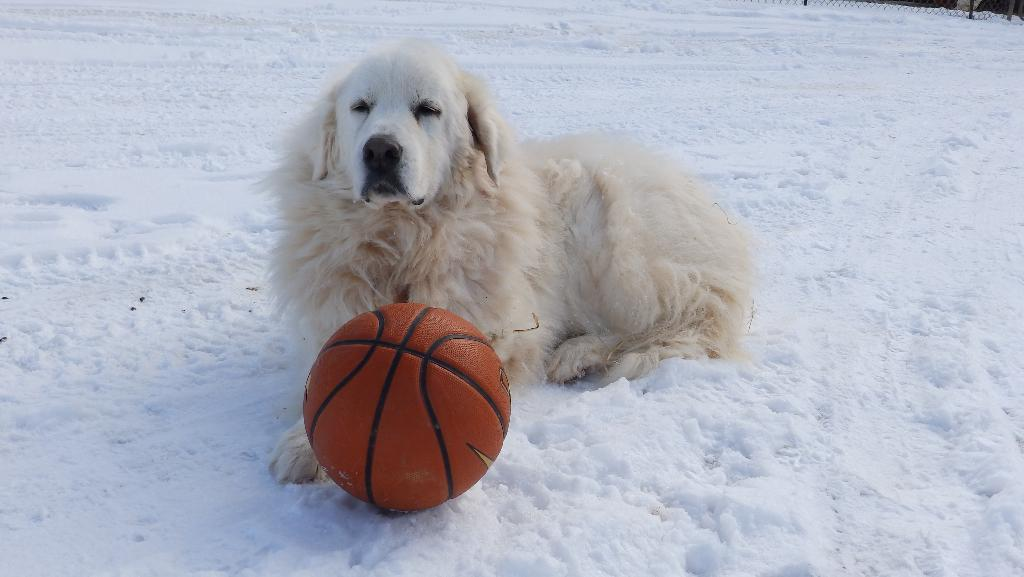What animal can be seen in the image? There is a dog in the image. Where is the dog located? The dog is laying on the snow. What object is in front of the dog? There is a ball in front of the dog. How many lizards are crawling on the dog in the image? There are no lizards present in the image; it features a dog laying on the snow with a ball in front of it. 